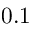Convert formula to latex. <formula><loc_0><loc_0><loc_500><loc_500>0 . 1</formula> 